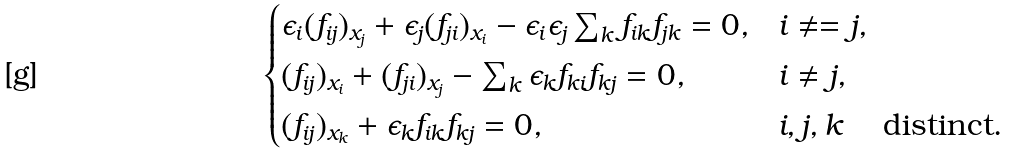Convert formula to latex. <formula><loc_0><loc_0><loc_500><loc_500>\begin{cases} \epsilon _ { i } ( f _ { i j } ) _ { x _ { j } } + \epsilon _ { j } ( f _ { j i } ) _ { x _ { i } } - \epsilon _ { i } \epsilon _ { j } \sum _ { k } f _ { i k } f _ { j k } = 0 , & i \neq = j , \\ ( f _ { i j } ) _ { x _ { i } } + ( f _ { j i } ) _ { x _ { j } } - \sum _ { k } \epsilon _ { k } f _ { k i } f _ { k j } = 0 , & i \neq j , \\ ( f _ { i j } ) _ { x _ { k } } + \epsilon _ { k } f _ { i k } f _ { k j } = 0 , & i , j , k \quad \text { distinct} . \end{cases}</formula> 